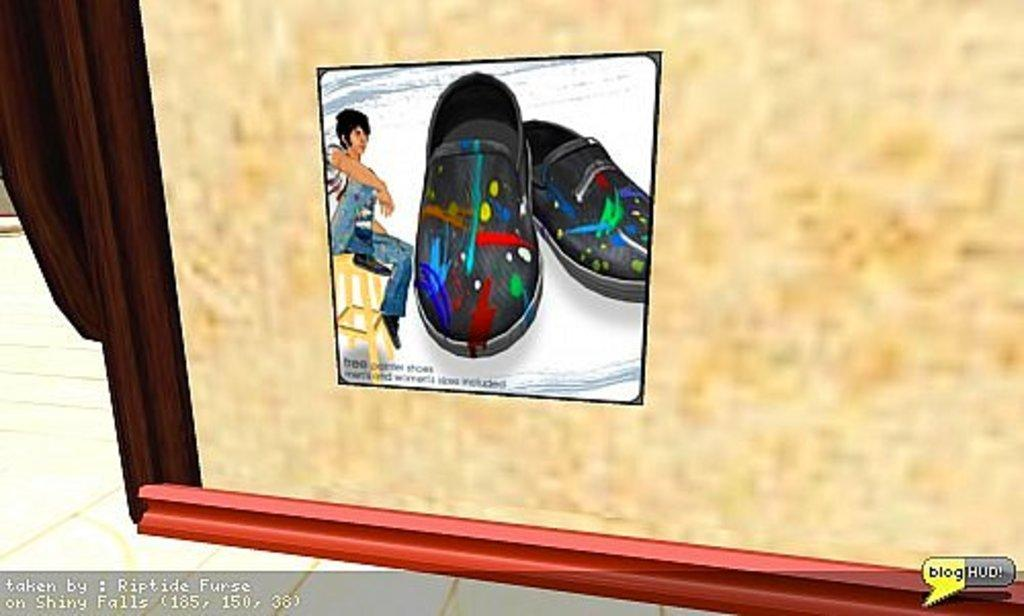What type of image is being described? The image is an animated picture. What objects can be seen in the image? There are shoes visible in the image. What is the person in the image doing? There is a person sitting on a chair in the image. What type of thrill can be seen in the image? There is no thrill present in the image; it is an animated picture featuring shoes and a person sitting on a chair. Can you spot a squirrel in the image? There is no squirrel present in the image. 